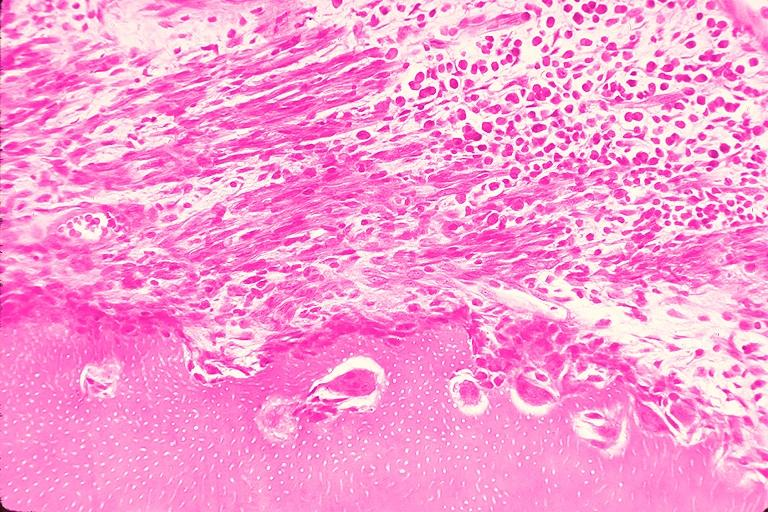s oral present?
Answer the question using a single word or phrase. Yes 